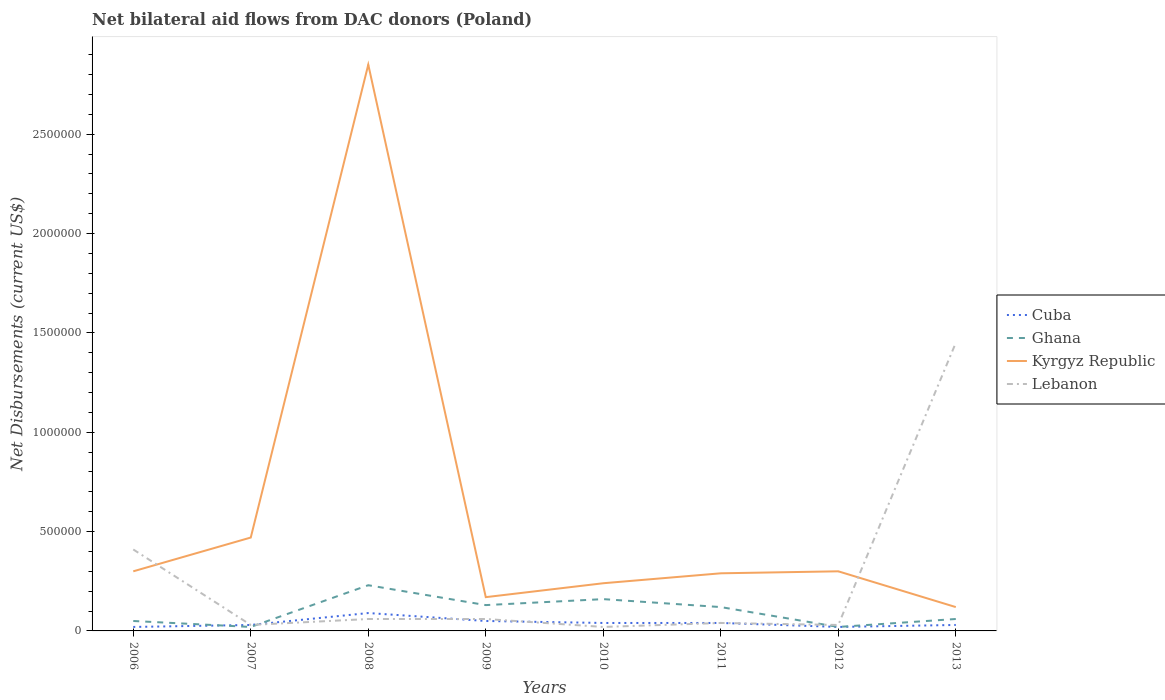How many different coloured lines are there?
Provide a short and direct response. 4. Does the line corresponding to Kyrgyz Republic intersect with the line corresponding to Cuba?
Provide a short and direct response. No. Across all years, what is the maximum net bilateral aid flows in Kyrgyz Republic?
Make the answer very short. 1.20e+05. What is the total net bilateral aid flows in Ghana in the graph?
Offer a terse response. -10000. What is the difference between the highest and the second highest net bilateral aid flows in Ghana?
Offer a terse response. 2.10e+05. What is the difference between the highest and the lowest net bilateral aid flows in Ghana?
Your response must be concise. 4. Is the net bilateral aid flows in Kyrgyz Republic strictly greater than the net bilateral aid flows in Ghana over the years?
Offer a very short reply. No. How many lines are there?
Offer a terse response. 4. How many years are there in the graph?
Your response must be concise. 8. What is the difference between two consecutive major ticks on the Y-axis?
Give a very brief answer. 5.00e+05. What is the title of the graph?
Your response must be concise. Net bilateral aid flows from DAC donors (Poland). What is the label or title of the Y-axis?
Your response must be concise. Net Disbursements (current US$). What is the Net Disbursements (current US$) in Cuba in 2006?
Your answer should be compact. 2.00e+04. What is the Net Disbursements (current US$) of Kyrgyz Republic in 2006?
Offer a terse response. 3.00e+05. What is the Net Disbursements (current US$) of Kyrgyz Republic in 2007?
Your answer should be compact. 4.70e+05. What is the Net Disbursements (current US$) in Cuba in 2008?
Your answer should be compact. 9.00e+04. What is the Net Disbursements (current US$) of Ghana in 2008?
Keep it short and to the point. 2.30e+05. What is the Net Disbursements (current US$) of Kyrgyz Republic in 2008?
Your response must be concise. 2.85e+06. What is the Net Disbursements (current US$) in Lebanon in 2008?
Your answer should be compact. 6.00e+04. What is the Net Disbursements (current US$) in Ghana in 2009?
Offer a very short reply. 1.30e+05. What is the Net Disbursements (current US$) in Lebanon in 2009?
Your response must be concise. 6.00e+04. What is the Net Disbursements (current US$) of Cuba in 2010?
Your answer should be very brief. 4.00e+04. What is the Net Disbursements (current US$) in Ghana in 2010?
Offer a very short reply. 1.60e+05. What is the Net Disbursements (current US$) in Kyrgyz Republic in 2010?
Offer a very short reply. 2.40e+05. What is the Net Disbursements (current US$) of Kyrgyz Republic in 2011?
Your answer should be compact. 2.90e+05. What is the Net Disbursements (current US$) in Lebanon in 2011?
Make the answer very short. 4.00e+04. What is the Net Disbursements (current US$) of Lebanon in 2012?
Give a very brief answer. 3.00e+04. What is the Net Disbursements (current US$) of Cuba in 2013?
Provide a succinct answer. 3.00e+04. What is the Net Disbursements (current US$) of Ghana in 2013?
Give a very brief answer. 6.00e+04. What is the Net Disbursements (current US$) in Kyrgyz Republic in 2013?
Your answer should be very brief. 1.20e+05. What is the Net Disbursements (current US$) in Lebanon in 2013?
Ensure brevity in your answer.  1.45e+06. Across all years, what is the maximum Net Disbursements (current US$) of Ghana?
Ensure brevity in your answer.  2.30e+05. Across all years, what is the maximum Net Disbursements (current US$) of Kyrgyz Republic?
Provide a short and direct response. 2.85e+06. Across all years, what is the maximum Net Disbursements (current US$) in Lebanon?
Provide a succinct answer. 1.45e+06. Across all years, what is the minimum Net Disbursements (current US$) in Ghana?
Offer a very short reply. 2.00e+04. Across all years, what is the minimum Net Disbursements (current US$) of Kyrgyz Republic?
Make the answer very short. 1.20e+05. Across all years, what is the minimum Net Disbursements (current US$) in Lebanon?
Ensure brevity in your answer.  2.00e+04. What is the total Net Disbursements (current US$) in Ghana in the graph?
Keep it short and to the point. 7.90e+05. What is the total Net Disbursements (current US$) of Kyrgyz Republic in the graph?
Your response must be concise. 4.74e+06. What is the total Net Disbursements (current US$) of Lebanon in the graph?
Provide a succinct answer. 2.10e+06. What is the difference between the Net Disbursements (current US$) in Cuba in 2006 and that in 2007?
Give a very brief answer. -10000. What is the difference between the Net Disbursements (current US$) in Kyrgyz Republic in 2006 and that in 2007?
Provide a short and direct response. -1.70e+05. What is the difference between the Net Disbursements (current US$) of Lebanon in 2006 and that in 2007?
Your answer should be compact. 3.80e+05. What is the difference between the Net Disbursements (current US$) of Cuba in 2006 and that in 2008?
Your response must be concise. -7.00e+04. What is the difference between the Net Disbursements (current US$) of Ghana in 2006 and that in 2008?
Keep it short and to the point. -1.80e+05. What is the difference between the Net Disbursements (current US$) in Kyrgyz Republic in 2006 and that in 2008?
Your answer should be very brief. -2.55e+06. What is the difference between the Net Disbursements (current US$) in Kyrgyz Republic in 2006 and that in 2009?
Your response must be concise. 1.30e+05. What is the difference between the Net Disbursements (current US$) of Lebanon in 2006 and that in 2009?
Offer a terse response. 3.50e+05. What is the difference between the Net Disbursements (current US$) of Cuba in 2006 and that in 2010?
Give a very brief answer. -2.00e+04. What is the difference between the Net Disbursements (current US$) of Ghana in 2006 and that in 2010?
Keep it short and to the point. -1.10e+05. What is the difference between the Net Disbursements (current US$) in Kyrgyz Republic in 2006 and that in 2012?
Provide a short and direct response. 0. What is the difference between the Net Disbursements (current US$) of Lebanon in 2006 and that in 2012?
Your answer should be very brief. 3.80e+05. What is the difference between the Net Disbursements (current US$) of Cuba in 2006 and that in 2013?
Offer a terse response. -10000. What is the difference between the Net Disbursements (current US$) in Kyrgyz Republic in 2006 and that in 2013?
Give a very brief answer. 1.80e+05. What is the difference between the Net Disbursements (current US$) in Lebanon in 2006 and that in 2013?
Offer a terse response. -1.04e+06. What is the difference between the Net Disbursements (current US$) of Cuba in 2007 and that in 2008?
Ensure brevity in your answer.  -6.00e+04. What is the difference between the Net Disbursements (current US$) of Ghana in 2007 and that in 2008?
Give a very brief answer. -2.10e+05. What is the difference between the Net Disbursements (current US$) in Kyrgyz Republic in 2007 and that in 2008?
Ensure brevity in your answer.  -2.38e+06. What is the difference between the Net Disbursements (current US$) of Ghana in 2007 and that in 2009?
Provide a succinct answer. -1.10e+05. What is the difference between the Net Disbursements (current US$) of Lebanon in 2007 and that in 2009?
Your answer should be very brief. -3.00e+04. What is the difference between the Net Disbursements (current US$) in Ghana in 2007 and that in 2010?
Ensure brevity in your answer.  -1.40e+05. What is the difference between the Net Disbursements (current US$) in Cuba in 2007 and that in 2011?
Keep it short and to the point. -10000. What is the difference between the Net Disbursements (current US$) in Kyrgyz Republic in 2007 and that in 2011?
Your response must be concise. 1.80e+05. What is the difference between the Net Disbursements (current US$) in Lebanon in 2007 and that in 2011?
Your answer should be very brief. -10000. What is the difference between the Net Disbursements (current US$) of Ghana in 2007 and that in 2012?
Provide a succinct answer. 0. What is the difference between the Net Disbursements (current US$) in Kyrgyz Republic in 2007 and that in 2012?
Offer a very short reply. 1.70e+05. What is the difference between the Net Disbursements (current US$) in Lebanon in 2007 and that in 2012?
Ensure brevity in your answer.  0. What is the difference between the Net Disbursements (current US$) in Cuba in 2007 and that in 2013?
Give a very brief answer. 0. What is the difference between the Net Disbursements (current US$) in Lebanon in 2007 and that in 2013?
Your response must be concise. -1.42e+06. What is the difference between the Net Disbursements (current US$) of Ghana in 2008 and that in 2009?
Provide a succinct answer. 1.00e+05. What is the difference between the Net Disbursements (current US$) in Kyrgyz Republic in 2008 and that in 2009?
Offer a very short reply. 2.68e+06. What is the difference between the Net Disbursements (current US$) of Ghana in 2008 and that in 2010?
Your answer should be compact. 7.00e+04. What is the difference between the Net Disbursements (current US$) of Kyrgyz Republic in 2008 and that in 2010?
Give a very brief answer. 2.61e+06. What is the difference between the Net Disbursements (current US$) in Lebanon in 2008 and that in 2010?
Your answer should be very brief. 4.00e+04. What is the difference between the Net Disbursements (current US$) of Cuba in 2008 and that in 2011?
Ensure brevity in your answer.  5.00e+04. What is the difference between the Net Disbursements (current US$) of Ghana in 2008 and that in 2011?
Ensure brevity in your answer.  1.10e+05. What is the difference between the Net Disbursements (current US$) of Kyrgyz Republic in 2008 and that in 2011?
Offer a terse response. 2.56e+06. What is the difference between the Net Disbursements (current US$) in Lebanon in 2008 and that in 2011?
Offer a very short reply. 2.00e+04. What is the difference between the Net Disbursements (current US$) of Cuba in 2008 and that in 2012?
Provide a succinct answer. 7.00e+04. What is the difference between the Net Disbursements (current US$) of Kyrgyz Republic in 2008 and that in 2012?
Make the answer very short. 2.55e+06. What is the difference between the Net Disbursements (current US$) of Kyrgyz Republic in 2008 and that in 2013?
Give a very brief answer. 2.73e+06. What is the difference between the Net Disbursements (current US$) of Lebanon in 2008 and that in 2013?
Your response must be concise. -1.39e+06. What is the difference between the Net Disbursements (current US$) in Cuba in 2009 and that in 2010?
Your answer should be very brief. 10000. What is the difference between the Net Disbursements (current US$) of Kyrgyz Republic in 2009 and that in 2010?
Offer a terse response. -7.00e+04. What is the difference between the Net Disbursements (current US$) of Lebanon in 2009 and that in 2010?
Your response must be concise. 4.00e+04. What is the difference between the Net Disbursements (current US$) in Kyrgyz Republic in 2009 and that in 2011?
Your response must be concise. -1.20e+05. What is the difference between the Net Disbursements (current US$) in Lebanon in 2009 and that in 2011?
Offer a terse response. 2.00e+04. What is the difference between the Net Disbursements (current US$) of Cuba in 2009 and that in 2012?
Your answer should be compact. 3.00e+04. What is the difference between the Net Disbursements (current US$) of Ghana in 2009 and that in 2012?
Give a very brief answer. 1.10e+05. What is the difference between the Net Disbursements (current US$) of Lebanon in 2009 and that in 2012?
Offer a terse response. 3.00e+04. What is the difference between the Net Disbursements (current US$) in Lebanon in 2009 and that in 2013?
Make the answer very short. -1.39e+06. What is the difference between the Net Disbursements (current US$) in Kyrgyz Republic in 2010 and that in 2011?
Give a very brief answer. -5.00e+04. What is the difference between the Net Disbursements (current US$) of Lebanon in 2010 and that in 2011?
Provide a short and direct response. -2.00e+04. What is the difference between the Net Disbursements (current US$) of Cuba in 2010 and that in 2012?
Ensure brevity in your answer.  2.00e+04. What is the difference between the Net Disbursements (current US$) of Kyrgyz Republic in 2010 and that in 2012?
Give a very brief answer. -6.00e+04. What is the difference between the Net Disbursements (current US$) in Lebanon in 2010 and that in 2012?
Your answer should be very brief. -10000. What is the difference between the Net Disbursements (current US$) of Cuba in 2010 and that in 2013?
Provide a succinct answer. 10000. What is the difference between the Net Disbursements (current US$) in Ghana in 2010 and that in 2013?
Provide a short and direct response. 1.00e+05. What is the difference between the Net Disbursements (current US$) of Kyrgyz Republic in 2010 and that in 2013?
Ensure brevity in your answer.  1.20e+05. What is the difference between the Net Disbursements (current US$) in Lebanon in 2010 and that in 2013?
Your response must be concise. -1.43e+06. What is the difference between the Net Disbursements (current US$) in Lebanon in 2011 and that in 2013?
Make the answer very short. -1.41e+06. What is the difference between the Net Disbursements (current US$) of Ghana in 2012 and that in 2013?
Keep it short and to the point. -4.00e+04. What is the difference between the Net Disbursements (current US$) of Kyrgyz Republic in 2012 and that in 2013?
Offer a very short reply. 1.80e+05. What is the difference between the Net Disbursements (current US$) of Lebanon in 2012 and that in 2013?
Provide a succinct answer. -1.42e+06. What is the difference between the Net Disbursements (current US$) of Cuba in 2006 and the Net Disbursements (current US$) of Kyrgyz Republic in 2007?
Give a very brief answer. -4.50e+05. What is the difference between the Net Disbursements (current US$) in Ghana in 2006 and the Net Disbursements (current US$) in Kyrgyz Republic in 2007?
Give a very brief answer. -4.20e+05. What is the difference between the Net Disbursements (current US$) of Ghana in 2006 and the Net Disbursements (current US$) of Lebanon in 2007?
Your answer should be very brief. 2.00e+04. What is the difference between the Net Disbursements (current US$) in Cuba in 2006 and the Net Disbursements (current US$) in Kyrgyz Republic in 2008?
Keep it short and to the point. -2.83e+06. What is the difference between the Net Disbursements (current US$) in Cuba in 2006 and the Net Disbursements (current US$) in Lebanon in 2008?
Offer a terse response. -4.00e+04. What is the difference between the Net Disbursements (current US$) in Ghana in 2006 and the Net Disbursements (current US$) in Kyrgyz Republic in 2008?
Give a very brief answer. -2.80e+06. What is the difference between the Net Disbursements (current US$) in Cuba in 2006 and the Net Disbursements (current US$) in Ghana in 2009?
Offer a terse response. -1.10e+05. What is the difference between the Net Disbursements (current US$) of Ghana in 2006 and the Net Disbursements (current US$) of Kyrgyz Republic in 2009?
Give a very brief answer. -1.20e+05. What is the difference between the Net Disbursements (current US$) of Ghana in 2006 and the Net Disbursements (current US$) of Lebanon in 2009?
Ensure brevity in your answer.  -10000. What is the difference between the Net Disbursements (current US$) of Kyrgyz Republic in 2006 and the Net Disbursements (current US$) of Lebanon in 2009?
Ensure brevity in your answer.  2.40e+05. What is the difference between the Net Disbursements (current US$) of Cuba in 2006 and the Net Disbursements (current US$) of Ghana in 2010?
Ensure brevity in your answer.  -1.40e+05. What is the difference between the Net Disbursements (current US$) in Ghana in 2006 and the Net Disbursements (current US$) in Kyrgyz Republic in 2010?
Provide a short and direct response. -1.90e+05. What is the difference between the Net Disbursements (current US$) in Ghana in 2006 and the Net Disbursements (current US$) in Lebanon in 2010?
Your response must be concise. 3.00e+04. What is the difference between the Net Disbursements (current US$) of Kyrgyz Republic in 2006 and the Net Disbursements (current US$) of Lebanon in 2010?
Provide a succinct answer. 2.80e+05. What is the difference between the Net Disbursements (current US$) in Cuba in 2006 and the Net Disbursements (current US$) in Kyrgyz Republic in 2011?
Provide a succinct answer. -2.70e+05. What is the difference between the Net Disbursements (current US$) of Cuba in 2006 and the Net Disbursements (current US$) of Lebanon in 2011?
Keep it short and to the point. -2.00e+04. What is the difference between the Net Disbursements (current US$) of Ghana in 2006 and the Net Disbursements (current US$) of Kyrgyz Republic in 2011?
Provide a short and direct response. -2.40e+05. What is the difference between the Net Disbursements (current US$) in Ghana in 2006 and the Net Disbursements (current US$) in Lebanon in 2011?
Your answer should be very brief. 10000. What is the difference between the Net Disbursements (current US$) in Cuba in 2006 and the Net Disbursements (current US$) in Ghana in 2012?
Provide a succinct answer. 0. What is the difference between the Net Disbursements (current US$) in Cuba in 2006 and the Net Disbursements (current US$) in Kyrgyz Republic in 2012?
Your answer should be compact. -2.80e+05. What is the difference between the Net Disbursements (current US$) of Ghana in 2006 and the Net Disbursements (current US$) of Kyrgyz Republic in 2012?
Your answer should be compact. -2.50e+05. What is the difference between the Net Disbursements (current US$) in Ghana in 2006 and the Net Disbursements (current US$) in Lebanon in 2012?
Give a very brief answer. 2.00e+04. What is the difference between the Net Disbursements (current US$) in Kyrgyz Republic in 2006 and the Net Disbursements (current US$) in Lebanon in 2012?
Provide a succinct answer. 2.70e+05. What is the difference between the Net Disbursements (current US$) in Cuba in 2006 and the Net Disbursements (current US$) in Ghana in 2013?
Offer a very short reply. -4.00e+04. What is the difference between the Net Disbursements (current US$) of Cuba in 2006 and the Net Disbursements (current US$) of Lebanon in 2013?
Provide a succinct answer. -1.43e+06. What is the difference between the Net Disbursements (current US$) in Ghana in 2006 and the Net Disbursements (current US$) in Kyrgyz Republic in 2013?
Your answer should be compact. -7.00e+04. What is the difference between the Net Disbursements (current US$) in Ghana in 2006 and the Net Disbursements (current US$) in Lebanon in 2013?
Provide a short and direct response. -1.40e+06. What is the difference between the Net Disbursements (current US$) in Kyrgyz Republic in 2006 and the Net Disbursements (current US$) in Lebanon in 2013?
Offer a terse response. -1.15e+06. What is the difference between the Net Disbursements (current US$) in Cuba in 2007 and the Net Disbursements (current US$) in Kyrgyz Republic in 2008?
Keep it short and to the point. -2.82e+06. What is the difference between the Net Disbursements (current US$) of Cuba in 2007 and the Net Disbursements (current US$) of Lebanon in 2008?
Offer a terse response. -3.00e+04. What is the difference between the Net Disbursements (current US$) in Ghana in 2007 and the Net Disbursements (current US$) in Kyrgyz Republic in 2008?
Ensure brevity in your answer.  -2.83e+06. What is the difference between the Net Disbursements (current US$) in Ghana in 2007 and the Net Disbursements (current US$) in Lebanon in 2008?
Give a very brief answer. -4.00e+04. What is the difference between the Net Disbursements (current US$) of Kyrgyz Republic in 2007 and the Net Disbursements (current US$) of Lebanon in 2008?
Your answer should be compact. 4.10e+05. What is the difference between the Net Disbursements (current US$) of Ghana in 2007 and the Net Disbursements (current US$) of Lebanon in 2009?
Provide a short and direct response. -4.00e+04. What is the difference between the Net Disbursements (current US$) of Kyrgyz Republic in 2007 and the Net Disbursements (current US$) of Lebanon in 2009?
Give a very brief answer. 4.10e+05. What is the difference between the Net Disbursements (current US$) in Ghana in 2007 and the Net Disbursements (current US$) in Kyrgyz Republic in 2010?
Your answer should be very brief. -2.20e+05. What is the difference between the Net Disbursements (current US$) of Kyrgyz Republic in 2007 and the Net Disbursements (current US$) of Lebanon in 2010?
Offer a very short reply. 4.50e+05. What is the difference between the Net Disbursements (current US$) in Cuba in 2007 and the Net Disbursements (current US$) in Kyrgyz Republic in 2012?
Make the answer very short. -2.70e+05. What is the difference between the Net Disbursements (current US$) in Cuba in 2007 and the Net Disbursements (current US$) in Lebanon in 2012?
Your answer should be compact. 0. What is the difference between the Net Disbursements (current US$) in Ghana in 2007 and the Net Disbursements (current US$) in Kyrgyz Republic in 2012?
Keep it short and to the point. -2.80e+05. What is the difference between the Net Disbursements (current US$) of Ghana in 2007 and the Net Disbursements (current US$) of Lebanon in 2012?
Provide a succinct answer. -10000. What is the difference between the Net Disbursements (current US$) of Cuba in 2007 and the Net Disbursements (current US$) of Ghana in 2013?
Your answer should be compact. -3.00e+04. What is the difference between the Net Disbursements (current US$) in Cuba in 2007 and the Net Disbursements (current US$) in Kyrgyz Republic in 2013?
Your answer should be very brief. -9.00e+04. What is the difference between the Net Disbursements (current US$) of Cuba in 2007 and the Net Disbursements (current US$) of Lebanon in 2013?
Provide a succinct answer. -1.42e+06. What is the difference between the Net Disbursements (current US$) of Ghana in 2007 and the Net Disbursements (current US$) of Lebanon in 2013?
Your response must be concise. -1.43e+06. What is the difference between the Net Disbursements (current US$) in Kyrgyz Republic in 2007 and the Net Disbursements (current US$) in Lebanon in 2013?
Provide a succinct answer. -9.80e+05. What is the difference between the Net Disbursements (current US$) in Cuba in 2008 and the Net Disbursements (current US$) in Lebanon in 2009?
Provide a short and direct response. 3.00e+04. What is the difference between the Net Disbursements (current US$) in Ghana in 2008 and the Net Disbursements (current US$) in Kyrgyz Republic in 2009?
Your answer should be very brief. 6.00e+04. What is the difference between the Net Disbursements (current US$) of Kyrgyz Republic in 2008 and the Net Disbursements (current US$) of Lebanon in 2009?
Provide a succinct answer. 2.79e+06. What is the difference between the Net Disbursements (current US$) in Cuba in 2008 and the Net Disbursements (current US$) in Ghana in 2010?
Keep it short and to the point. -7.00e+04. What is the difference between the Net Disbursements (current US$) of Cuba in 2008 and the Net Disbursements (current US$) of Kyrgyz Republic in 2010?
Ensure brevity in your answer.  -1.50e+05. What is the difference between the Net Disbursements (current US$) in Cuba in 2008 and the Net Disbursements (current US$) in Lebanon in 2010?
Your response must be concise. 7.00e+04. What is the difference between the Net Disbursements (current US$) of Kyrgyz Republic in 2008 and the Net Disbursements (current US$) of Lebanon in 2010?
Offer a terse response. 2.83e+06. What is the difference between the Net Disbursements (current US$) of Cuba in 2008 and the Net Disbursements (current US$) of Ghana in 2011?
Make the answer very short. -3.00e+04. What is the difference between the Net Disbursements (current US$) of Kyrgyz Republic in 2008 and the Net Disbursements (current US$) of Lebanon in 2011?
Your answer should be very brief. 2.81e+06. What is the difference between the Net Disbursements (current US$) in Cuba in 2008 and the Net Disbursements (current US$) in Kyrgyz Republic in 2012?
Ensure brevity in your answer.  -2.10e+05. What is the difference between the Net Disbursements (current US$) in Ghana in 2008 and the Net Disbursements (current US$) in Kyrgyz Republic in 2012?
Your response must be concise. -7.00e+04. What is the difference between the Net Disbursements (current US$) in Ghana in 2008 and the Net Disbursements (current US$) in Lebanon in 2012?
Offer a terse response. 2.00e+05. What is the difference between the Net Disbursements (current US$) in Kyrgyz Republic in 2008 and the Net Disbursements (current US$) in Lebanon in 2012?
Offer a very short reply. 2.82e+06. What is the difference between the Net Disbursements (current US$) of Cuba in 2008 and the Net Disbursements (current US$) of Ghana in 2013?
Your answer should be very brief. 3.00e+04. What is the difference between the Net Disbursements (current US$) in Cuba in 2008 and the Net Disbursements (current US$) in Lebanon in 2013?
Offer a terse response. -1.36e+06. What is the difference between the Net Disbursements (current US$) in Ghana in 2008 and the Net Disbursements (current US$) in Lebanon in 2013?
Provide a short and direct response. -1.22e+06. What is the difference between the Net Disbursements (current US$) of Kyrgyz Republic in 2008 and the Net Disbursements (current US$) of Lebanon in 2013?
Offer a very short reply. 1.40e+06. What is the difference between the Net Disbursements (current US$) of Cuba in 2009 and the Net Disbursements (current US$) of Ghana in 2010?
Give a very brief answer. -1.10e+05. What is the difference between the Net Disbursements (current US$) of Cuba in 2009 and the Net Disbursements (current US$) of Kyrgyz Republic in 2010?
Offer a very short reply. -1.90e+05. What is the difference between the Net Disbursements (current US$) in Ghana in 2009 and the Net Disbursements (current US$) in Kyrgyz Republic in 2010?
Keep it short and to the point. -1.10e+05. What is the difference between the Net Disbursements (current US$) of Kyrgyz Republic in 2009 and the Net Disbursements (current US$) of Lebanon in 2010?
Your answer should be compact. 1.50e+05. What is the difference between the Net Disbursements (current US$) of Cuba in 2009 and the Net Disbursements (current US$) of Ghana in 2011?
Offer a very short reply. -7.00e+04. What is the difference between the Net Disbursements (current US$) in Cuba in 2009 and the Net Disbursements (current US$) in Lebanon in 2011?
Offer a very short reply. 10000. What is the difference between the Net Disbursements (current US$) of Ghana in 2009 and the Net Disbursements (current US$) of Kyrgyz Republic in 2011?
Give a very brief answer. -1.60e+05. What is the difference between the Net Disbursements (current US$) in Ghana in 2009 and the Net Disbursements (current US$) in Lebanon in 2011?
Keep it short and to the point. 9.00e+04. What is the difference between the Net Disbursements (current US$) in Cuba in 2009 and the Net Disbursements (current US$) in Ghana in 2012?
Keep it short and to the point. 3.00e+04. What is the difference between the Net Disbursements (current US$) in Ghana in 2009 and the Net Disbursements (current US$) in Lebanon in 2012?
Offer a terse response. 1.00e+05. What is the difference between the Net Disbursements (current US$) in Cuba in 2009 and the Net Disbursements (current US$) in Lebanon in 2013?
Provide a short and direct response. -1.40e+06. What is the difference between the Net Disbursements (current US$) of Ghana in 2009 and the Net Disbursements (current US$) of Lebanon in 2013?
Offer a very short reply. -1.32e+06. What is the difference between the Net Disbursements (current US$) in Kyrgyz Republic in 2009 and the Net Disbursements (current US$) in Lebanon in 2013?
Provide a succinct answer. -1.28e+06. What is the difference between the Net Disbursements (current US$) of Cuba in 2010 and the Net Disbursements (current US$) of Kyrgyz Republic in 2011?
Offer a terse response. -2.50e+05. What is the difference between the Net Disbursements (current US$) in Cuba in 2010 and the Net Disbursements (current US$) in Lebanon in 2011?
Your answer should be compact. 0. What is the difference between the Net Disbursements (current US$) in Ghana in 2010 and the Net Disbursements (current US$) in Lebanon in 2011?
Offer a very short reply. 1.20e+05. What is the difference between the Net Disbursements (current US$) of Cuba in 2010 and the Net Disbursements (current US$) of Kyrgyz Republic in 2012?
Your response must be concise. -2.60e+05. What is the difference between the Net Disbursements (current US$) of Cuba in 2010 and the Net Disbursements (current US$) of Lebanon in 2012?
Keep it short and to the point. 10000. What is the difference between the Net Disbursements (current US$) in Ghana in 2010 and the Net Disbursements (current US$) in Kyrgyz Republic in 2012?
Your answer should be very brief. -1.40e+05. What is the difference between the Net Disbursements (current US$) in Cuba in 2010 and the Net Disbursements (current US$) in Ghana in 2013?
Give a very brief answer. -2.00e+04. What is the difference between the Net Disbursements (current US$) of Cuba in 2010 and the Net Disbursements (current US$) of Kyrgyz Republic in 2013?
Give a very brief answer. -8.00e+04. What is the difference between the Net Disbursements (current US$) in Cuba in 2010 and the Net Disbursements (current US$) in Lebanon in 2013?
Keep it short and to the point. -1.41e+06. What is the difference between the Net Disbursements (current US$) of Ghana in 2010 and the Net Disbursements (current US$) of Kyrgyz Republic in 2013?
Your answer should be compact. 4.00e+04. What is the difference between the Net Disbursements (current US$) of Ghana in 2010 and the Net Disbursements (current US$) of Lebanon in 2013?
Ensure brevity in your answer.  -1.29e+06. What is the difference between the Net Disbursements (current US$) in Kyrgyz Republic in 2010 and the Net Disbursements (current US$) in Lebanon in 2013?
Provide a short and direct response. -1.21e+06. What is the difference between the Net Disbursements (current US$) in Cuba in 2011 and the Net Disbursements (current US$) in Lebanon in 2012?
Keep it short and to the point. 10000. What is the difference between the Net Disbursements (current US$) of Ghana in 2011 and the Net Disbursements (current US$) of Kyrgyz Republic in 2012?
Keep it short and to the point. -1.80e+05. What is the difference between the Net Disbursements (current US$) in Ghana in 2011 and the Net Disbursements (current US$) in Lebanon in 2012?
Ensure brevity in your answer.  9.00e+04. What is the difference between the Net Disbursements (current US$) of Cuba in 2011 and the Net Disbursements (current US$) of Kyrgyz Republic in 2013?
Ensure brevity in your answer.  -8.00e+04. What is the difference between the Net Disbursements (current US$) of Cuba in 2011 and the Net Disbursements (current US$) of Lebanon in 2013?
Give a very brief answer. -1.41e+06. What is the difference between the Net Disbursements (current US$) in Ghana in 2011 and the Net Disbursements (current US$) in Kyrgyz Republic in 2013?
Offer a terse response. 0. What is the difference between the Net Disbursements (current US$) in Ghana in 2011 and the Net Disbursements (current US$) in Lebanon in 2013?
Provide a short and direct response. -1.33e+06. What is the difference between the Net Disbursements (current US$) in Kyrgyz Republic in 2011 and the Net Disbursements (current US$) in Lebanon in 2013?
Offer a terse response. -1.16e+06. What is the difference between the Net Disbursements (current US$) of Cuba in 2012 and the Net Disbursements (current US$) of Ghana in 2013?
Your answer should be compact. -4.00e+04. What is the difference between the Net Disbursements (current US$) of Cuba in 2012 and the Net Disbursements (current US$) of Lebanon in 2013?
Offer a very short reply. -1.43e+06. What is the difference between the Net Disbursements (current US$) of Ghana in 2012 and the Net Disbursements (current US$) of Lebanon in 2013?
Your answer should be very brief. -1.43e+06. What is the difference between the Net Disbursements (current US$) in Kyrgyz Republic in 2012 and the Net Disbursements (current US$) in Lebanon in 2013?
Your answer should be compact. -1.15e+06. What is the average Net Disbursements (current US$) in Cuba per year?
Make the answer very short. 4.00e+04. What is the average Net Disbursements (current US$) of Ghana per year?
Your answer should be compact. 9.88e+04. What is the average Net Disbursements (current US$) in Kyrgyz Republic per year?
Keep it short and to the point. 5.92e+05. What is the average Net Disbursements (current US$) of Lebanon per year?
Give a very brief answer. 2.62e+05. In the year 2006, what is the difference between the Net Disbursements (current US$) in Cuba and Net Disbursements (current US$) in Kyrgyz Republic?
Offer a terse response. -2.80e+05. In the year 2006, what is the difference between the Net Disbursements (current US$) in Cuba and Net Disbursements (current US$) in Lebanon?
Your response must be concise. -3.90e+05. In the year 2006, what is the difference between the Net Disbursements (current US$) in Ghana and Net Disbursements (current US$) in Kyrgyz Republic?
Make the answer very short. -2.50e+05. In the year 2006, what is the difference between the Net Disbursements (current US$) in Ghana and Net Disbursements (current US$) in Lebanon?
Provide a short and direct response. -3.60e+05. In the year 2007, what is the difference between the Net Disbursements (current US$) of Cuba and Net Disbursements (current US$) of Kyrgyz Republic?
Offer a very short reply. -4.40e+05. In the year 2007, what is the difference between the Net Disbursements (current US$) of Ghana and Net Disbursements (current US$) of Kyrgyz Republic?
Offer a very short reply. -4.50e+05. In the year 2007, what is the difference between the Net Disbursements (current US$) of Kyrgyz Republic and Net Disbursements (current US$) of Lebanon?
Your answer should be very brief. 4.40e+05. In the year 2008, what is the difference between the Net Disbursements (current US$) of Cuba and Net Disbursements (current US$) of Ghana?
Your response must be concise. -1.40e+05. In the year 2008, what is the difference between the Net Disbursements (current US$) in Cuba and Net Disbursements (current US$) in Kyrgyz Republic?
Provide a succinct answer. -2.76e+06. In the year 2008, what is the difference between the Net Disbursements (current US$) in Cuba and Net Disbursements (current US$) in Lebanon?
Ensure brevity in your answer.  3.00e+04. In the year 2008, what is the difference between the Net Disbursements (current US$) in Ghana and Net Disbursements (current US$) in Kyrgyz Republic?
Ensure brevity in your answer.  -2.62e+06. In the year 2008, what is the difference between the Net Disbursements (current US$) in Ghana and Net Disbursements (current US$) in Lebanon?
Provide a succinct answer. 1.70e+05. In the year 2008, what is the difference between the Net Disbursements (current US$) of Kyrgyz Republic and Net Disbursements (current US$) of Lebanon?
Provide a short and direct response. 2.79e+06. In the year 2009, what is the difference between the Net Disbursements (current US$) of Cuba and Net Disbursements (current US$) of Ghana?
Provide a short and direct response. -8.00e+04. In the year 2009, what is the difference between the Net Disbursements (current US$) in Cuba and Net Disbursements (current US$) in Kyrgyz Republic?
Your answer should be very brief. -1.20e+05. In the year 2009, what is the difference between the Net Disbursements (current US$) of Ghana and Net Disbursements (current US$) of Kyrgyz Republic?
Keep it short and to the point. -4.00e+04. In the year 2009, what is the difference between the Net Disbursements (current US$) in Kyrgyz Republic and Net Disbursements (current US$) in Lebanon?
Your response must be concise. 1.10e+05. In the year 2010, what is the difference between the Net Disbursements (current US$) of Cuba and Net Disbursements (current US$) of Kyrgyz Republic?
Provide a succinct answer. -2.00e+05. In the year 2010, what is the difference between the Net Disbursements (current US$) in Ghana and Net Disbursements (current US$) in Lebanon?
Offer a terse response. 1.40e+05. In the year 2010, what is the difference between the Net Disbursements (current US$) in Kyrgyz Republic and Net Disbursements (current US$) in Lebanon?
Your answer should be very brief. 2.20e+05. In the year 2011, what is the difference between the Net Disbursements (current US$) in Cuba and Net Disbursements (current US$) in Kyrgyz Republic?
Offer a terse response. -2.50e+05. In the year 2011, what is the difference between the Net Disbursements (current US$) of Kyrgyz Republic and Net Disbursements (current US$) of Lebanon?
Your answer should be compact. 2.50e+05. In the year 2012, what is the difference between the Net Disbursements (current US$) of Cuba and Net Disbursements (current US$) of Ghana?
Offer a terse response. 0. In the year 2012, what is the difference between the Net Disbursements (current US$) in Cuba and Net Disbursements (current US$) in Kyrgyz Republic?
Provide a short and direct response. -2.80e+05. In the year 2012, what is the difference between the Net Disbursements (current US$) of Cuba and Net Disbursements (current US$) of Lebanon?
Your response must be concise. -10000. In the year 2012, what is the difference between the Net Disbursements (current US$) of Ghana and Net Disbursements (current US$) of Kyrgyz Republic?
Your response must be concise. -2.80e+05. In the year 2012, what is the difference between the Net Disbursements (current US$) of Kyrgyz Republic and Net Disbursements (current US$) of Lebanon?
Your response must be concise. 2.70e+05. In the year 2013, what is the difference between the Net Disbursements (current US$) of Cuba and Net Disbursements (current US$) of Ghana?
Your answer should be very brief. -3.00e+04. In the year 2013, what is the difference between the Net Disbursements (current US$) in Cuba and Net Disbursements (current US$) in Kyrgyz Republic?
Provide a short and direct response. -9.00e+04. In the year 2013, what is the difference between the Net Disbursements (current US$) of Cuba and Net Disbursements (current US$) of Lebanon?
Provide a short and direct response. -1.42e+06. In the year 2013, what is the difference between the Net Disbursements (current US$) in Ghana and Net Disbursements (current US$) in Lebanon?
Ensure brevity in your answer.  -1.39e+06. In the year 2013, what is the difference between the Net Disbursements (current US$) of Kyrgyz Republic and Net Disbursements (current US$) of Lebanon?
Your answer should be very brief. -1.33e+06. What is the ratio of the Net Disbursements (current US$) in Ghana in 2006 to that in 2007?
Offer a terse response. 2.5. What is the ratio of the Net Disbursements (current US$) in Kyrgyz Republic in 2006 to that in 2007?
Your answer should be very brief. 0.64. What is the ratio of the Net Disbursements (current US$) in Lebanon in 2006 to that in 2007?
Make the answer very short. 13.67. What is the ratio of the Net Disbursements (current US$) of Cuba in 2006 to that in 2008?
Make the answer very short. 0.22. What is the ratio of the Net Disbursements (current US$) of Ghana in 2006 to that in 2008?
Your answer should be compact. 0.22. What is the ratio of the Net Disbursements (current US$) of Kyrgyz Republic in 2006 to that in 2008?
Keep it short and to the point. 0.11. What is the ratio of the Net Disbursements (current US$) in Lebanon in 2006 to that in 2008?
Provide a short and direct response. 6.83. What is the ratio of the Net Disbursements (current US$) of Ghana in 2006 to that in 2009?
Ensure brevity in your answer.  0.38. What is the ratio of the Net Disbursements (current US$) in Kyrgyz Republic in 2006 to that in 2009?
Your response must be concise. 1.76. What is the ratio of the Net Disbursements (current US$) of Lebanon in 2006 to that in 2009?
Provide a succinct answer. 6.83. What is the ratio of the Net Disbursements (current US$) in Ghana in 2006 to that in 2010?
Make the answer very short. 0.31. What is the ratio of the Net Disbursements (current US$) of Lebanon in 2006 to that in 2010?
Your response must be concise. 20.5. What is the ratio of the Net Disbursements (current US$) in Cuba in 2006 to that in 2011?
Your answer should be compact. 0.5. What is the ratio of the Net Disbursements (current US$) in Ghana in 2006 to that in 2011?
Provide a short and direct response. 0.42. What is the ratio of the Net Disbursements (current US$) in Kyrgyz Republic in 2006 to that in 2011?
Your answer should be compact. 1.03. What is the ratio of the Net Disbursements (current US$) in Lebanon in 2006 to that in 2011?
Offer a very short reply. 10.25. What is the ratio of the Net Disbursements (current US$) in Ghana in 2006 to that in 2012?
Your answer should be very brief. 2.5. What is the ratio of the Net Disbursements (current US$) of Lebanon in 2006 to that in 2012?
Your answer should be very brief. 13.67. What is the ratio of the Net Disbursements (current US$) in Kyrgyz Republic in 2006 to that in 2013?
Your response must be concise. 2.5. What is the ratio of the Net Disbursements (current US$) of Lebanon in 2006 to that in 2013?
Give a very brief answer. 0.28. What is the ratio of the Net Disbursements (current US$) of Cuba in 2007 to that in 2008?
Your answer should be very brief. 0.33. What is the ratio of the Net Disbursements (current US$) of Ghana in 2007 to that in 2008?
Offer a very short reply. 0.09. What is the ratio of the Net Disbursements (current US$) in Kyrgyz Republic in 2007 to that in 2008?
Your answer should be very brief. 0.16. What is the ratio of the Net Disbursements (current US$) in Cuba in 2007 to that in 2009?
Give a very brief answer. 0.6. What is the ratio of the Net Disbursements (current US$) of Ghana in 2007 to that in 2009?
Keep it short and to the point. 0.15. What is the ratio of the Net Disbursements (current US$) of Kyrgyz Republic in 2007 to that in 2009?
Give a very brief answer. 2.76. What is the ratio of the Net Disbursements (current US$) in Cuba in 2007 to that in 2010?
Keep it short and to the point. 0.75. What is the ratio of the Net Disbursements (current US$) of Kyrgyz Republic in 2007 to that in 2010?
Your answer should be very brief. 1.96. What is the ratio of the Net Disbursements (current US$) of Ghana in 2007 to that in 2011?
Ensure brevity in your answer.  0.17. What is the ratio of the Net Disbursements (current US$) in Kyrgyz Republic in 2007 to that in 2011?
Your response must be concise. 1.62. What is the ratio of the Net Disbursements (current US$) in Kyrgyz Republic in 2007 to that in 2012?
Your answer should be very brief. 1.57. What is the ratio of the Net Disbursements (current US$) of Kyrgyz Republic in 2007 to that in 2013?
Make the answer very short. 3.92. What is the ratio of the Net Disbursements (current US$) of Lebanon in 2007 to that in 2013?
Offer a very short reply. 0.02. What is the ratio of the Net Disbursements (current US$) of Cuba in 2008 to that in 2009?
Provide a succinct answer. 1.8. What is the ratio of the Net Disbursements (current US$) of Ghana in 2008 to that in 2009?
Offer a very short reply. 1.77. What is the ratio of the Net Disbursements (current US$) in Kyrgyz Republic in 2008 to that in 2009?
Ensure brevity in your answer.  16.76. What is the ratio of the Net Disbursements (current US$) of Cuba in 2008 to that in 2010?
Give a very brief answer. 2.25. What is the ratio of the Net Disbursements (current US$) in Ghana in 2008 to that in 2010?
Offer a terse response. 1.44. What is the ratio of the Net Disbursements (current US$) of Kyrgyz Republic in 2008 to that in 2010?
Provide a short and direct response. 11.88. What is the ratio of the Net Disbursements (current US$) of Cuba in 2008 to that in 2011?
Your answer should be compact. 2.25. What is the ratio of the Net Disbursements (current US$) in Ghana in 2008 to that in 2011?
Keep it short and to the point. 1.92. What is the ratio of the Net Disbursements (current US$) of Kyrgyz Republic in 2008 to that in 2011?
Ensure brevity in your answer.  9.83. What is the ratio of the Net Disbursements (current US$) of Ghana in 2008 to that in 2012?
Provide a short and direct response. 11.5. What is the ratio of the Net Disbursements (current US$) in Lebanon in 2008 to that in 2012?
Provide a succinct answer. 2. What is the ratio of the Net Disbursements (current US$) of Cuba in 2008 to that in 2013?
Offer a terse response. 3. What is the ratio of the Net Disbursements (current US$) of Ghana in 2008 to that in 2013?
Make the answer very short. 3.83. What is the ratio of the Net Disbursements (current US$) in Kyrgyz Republic in 2008 to that in 2013?
Your response must be concise. 23.75. What is the ratio of the Net Disbursements (current US$) of Lebanon in 2008 to that in 2013?
Provide a short and direct response. 0.04. What is the ratio of the Net Disbursements (current US$) in Cuba in 2009 to that in 2010?
Your response must be concise. 1.25. What is the ratio of the Net Disbursements (current US$) of Ghana in 2009 to that in 2010?
Your response must be concise. 0.81. What is the ratio of the Net Disbursements (current US$) of Kyrgyz Republic in 2009 to that in 2010?
Provide a succinct answer. 0.71. What is the ratio of the Net Disbursements (current US$) in Cuba in 2009 to that in 2011?
Provide a succinct answer. 1.25. What is the ratio of the Net Disbursements (current US$) in Kyrgyz Republic in 2009 to that in 2011?
Your answer should be very brief. 0.59. What is the ratio of the Net Disbursements (current US$) in Cuba in 2009 to that in 2012?
Offer a terse response. 2.5. What is the ratio of the Net Disbursements (current US$) of Ghana in 2009 to that in 2012?
Make the answer very short. 6.5. What is the ratio of the Net Disbursements (current US$) in Kyrgyz Republic in 2009 to that in 2012?
Your answer should be compact. 0.57. What is the ratio of the Net Disbursements (current US$) of Ghana in 2009 to that in 2013?
Make the answer very short. 2.17. What is the ratio of the Net Disbursements (current US$) in Kyrgyz Republic in 2009 to that in 2013?
Ensure brevity in your answer.  1.42. What is the ratio of the Net Disbursements (current US$) of Lebanon in 2009 to that in 2013?
Provide a succinct answer. 0.04. What is the ratio of the Net Disbursements (current US$) in Kyrgyz Republic in 2010 to that in 2011?
Your answer should be compact. 0.83. What is the ratio of the Net Disbursements (current US$) in Lebanon in 2010 to that in 2011?
Provide a short and direct response. 0.5. What is the ratio of the Net Disbursements (current US$) in Ghana in 2010 to that in 2012?
Your answer should be very brief. 8. What is the ratio of the Net Disbursements (current US$) of Lebanon in 2010 to that in 2012?
Offer a very short reply. 0.67. What is the ratio of the Net Disbursements (current US$) of Ghana in 2010 to that in 2013?
Offer a very short reply. 2.67. What is the ratio of the Net Disbursements (current US$) in Lebanon in 2010 to that in 2013?
Your response must be concise. 0.01. What is the ratio of the Net Disbursements (current US$) in Cuba in 2011 to that in 2012?
Provide a succinct answer. 2. What is the ratio of the Net Disbursements (current US$) in Ghana in 2011 to that in 2012?
Your response must be concise. 6. What is the ratio of the Net Disbursements (current US$) in Kyrgyz Republic in 2011 to that in 2012?
Your answer should be very brief. 0.97. What is the ratio of the Net Disbursements (current US$) of Lebanon in 2011 to that in 2012?
Provide a succinct answer. 1.33. What is the ratio of the Net Disbursements (current US$) of Cuba in 2011 to that in 2013?
Provide a short and direct response. 1.33. What is the ratio of the Net Disbursements (current US$) of Kyrgyz Republic in 2011 to that in 2013?
Your answer should be very brief. 2.42. What is the ratio of the Net Disbursements (current US$) in Lebanon in 2011 to that in 2013?
Provide a succinct answer. 0.03. What is the ratio of the Net Disbursements (current US$) of Cuba in 2012 to that in 2013?
Offer a terse response. 0.67. What is the ratio of the Net Disbursements (current US$) of Ghana in 2012 to that in 2013?
Your answer should be very brief. 0.33. What is the ratio of the Net Disbursements (current US$) in Kyrgyz Republic in 2012 to that in 2013?
Provide a short and direct response. 2.5. What is the ratio of the Net Disbursements (current US$) in Lebanon in 2012 to that in 2013?
Your response must be concise. 0.02. What is the difference between the highest and the second highest Net Disbursements (current US$) of Kyrgyz Republic?
Keep it short and to the point. 2.38e+06. What is the difference between the highest and the second highest Net Disbursements (current US$) of Lebanon?
Keep it short and to the point. 1.04e+06. What is the difference between the highest and the lowest Net Disbursements (current US$) of Ghana?
Offer a very short reply. 2.10e+05. What is the difference between the highest and the lowest Net Disbursements (current US$) of Kyrgyz Republic?
Provide a succinct answer. 2.73e+06. What is the difference between the highest and the lowest Net Disbursements (current US$) in Lebanon?
Your answer should be compact. 1.43e+06. 